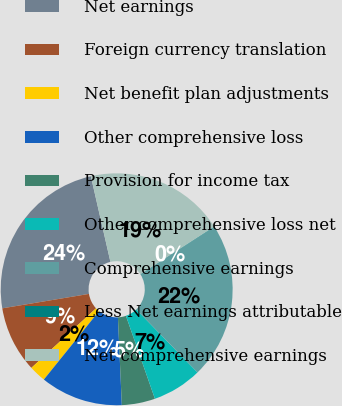<chart> <loc_0><loc_0><loc_500><loc_500><pie_chart><fcel>Net earnings<fcel>Foreign currency translation<fcel>Net benefit plan adjustments<fcel>Other comprehensive loss<fcel>Provision for income tax<fcel>Other comprehensive loss net<fcel>Comprehensive earnings<fcel>Less Net earnings attributable<fcel>Net comprehensive earnings<nl><fcel>24.05%<fcel>9.22%<fcel>2.35%<fcel>11.51%<fcel>4.64%<fcel>6.93%<fcel>21.76%<fcel>0.06%<fcel>19.47%<nl></chart> 